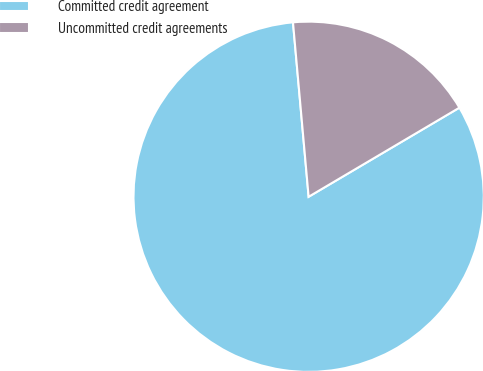<chart> <loc_0><loc_0><loc_500><loc_500><pie_chart><fcel>Committed credit agreement<fcel>Uncommitted credit agreements<nl><fcel>82.07%<fcel>17.93%<nl></chart> 